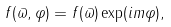<formula> <loc_0><loc_0><loc_500><loc_500>f ( \varpi , \varphi ) = f ( \varpi ) \exp ( i m \varphi ) ,</formula> 